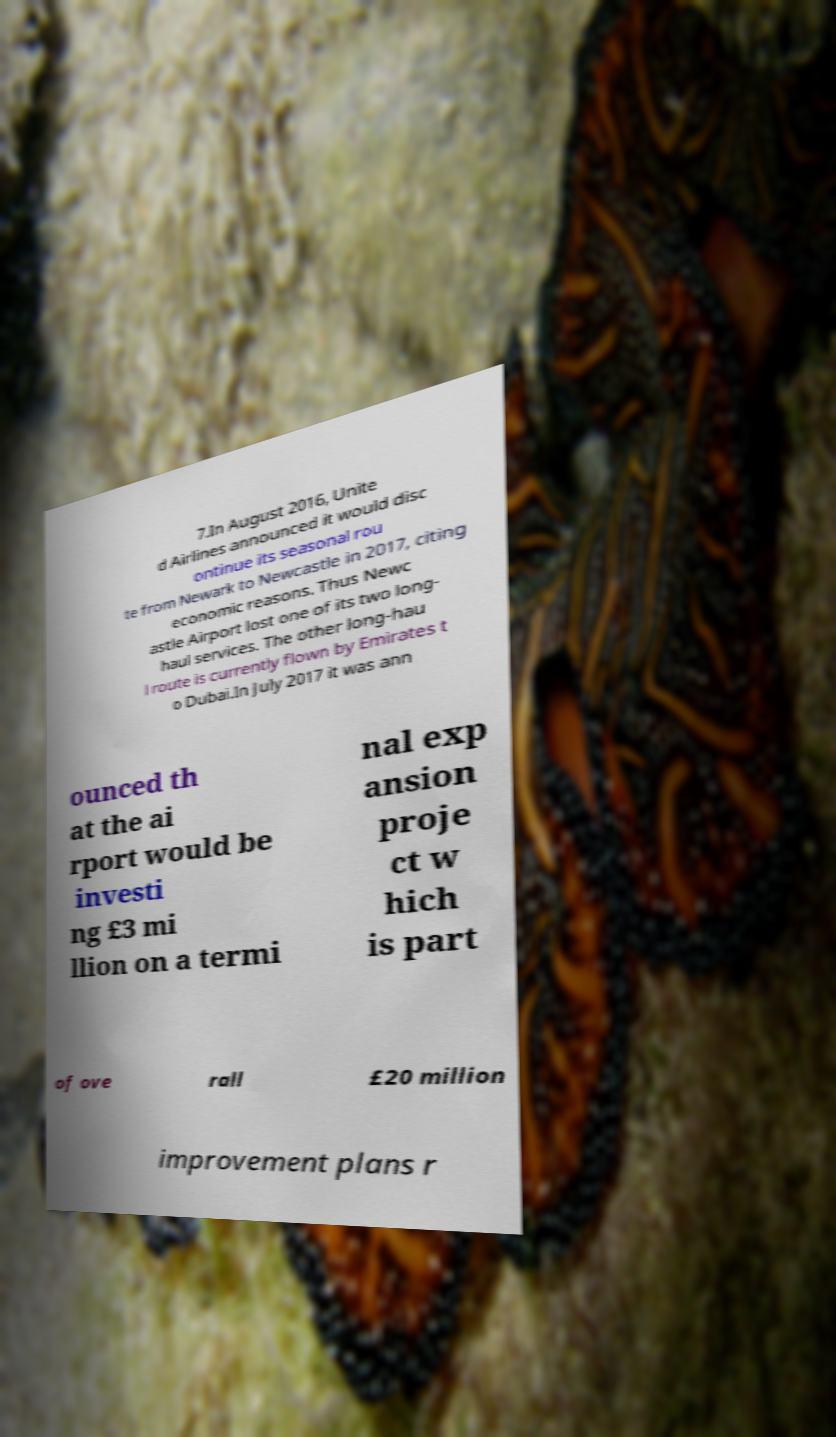For documentation purposes, I need the text within this image transcribed. Could you provide that? 7.In August 2016, Unite d Airlines announced it would disc ontinue its seasonal rou te from Newark to Newcastle in 2017, citing economic reasons. Thus Newc astle Airport lost one of its two long- haul services. The other long-hau l route is currently flown by Emirates t o Dubai.In July 2017 it was ann ounced th at the ai rport would be investi ng £3 mi llion on a termi nal exp ansion proje ct w hich is part of ove rall £20 million improvement plans r 